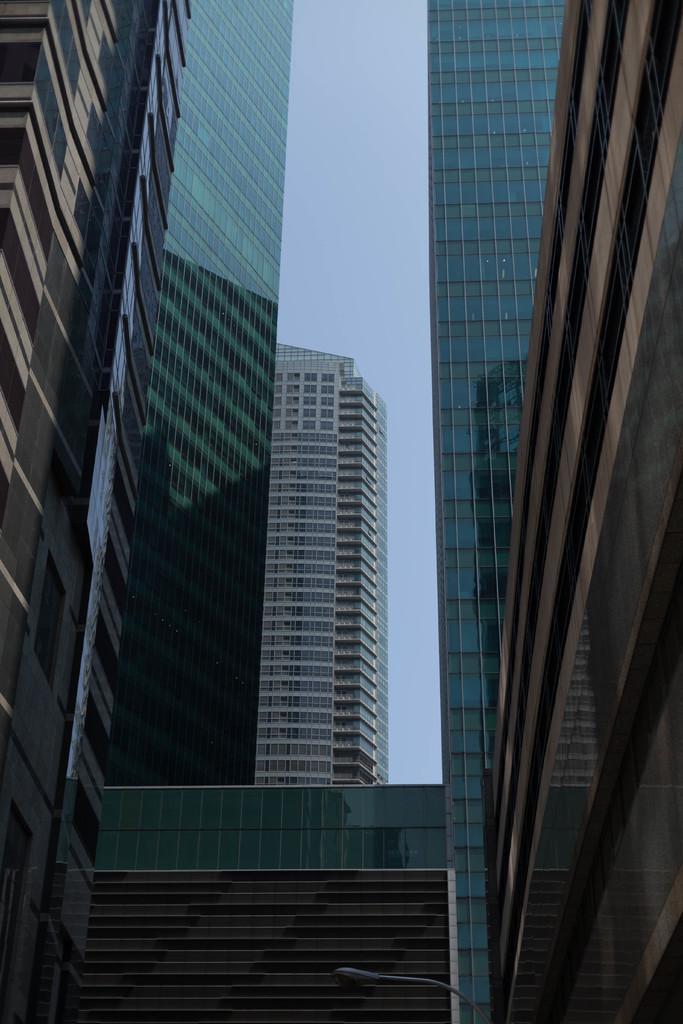In one or two sentences, can you explain what this image depicts? In this picture i can see the skyscrapers and buildings. At the top there is a sky. 